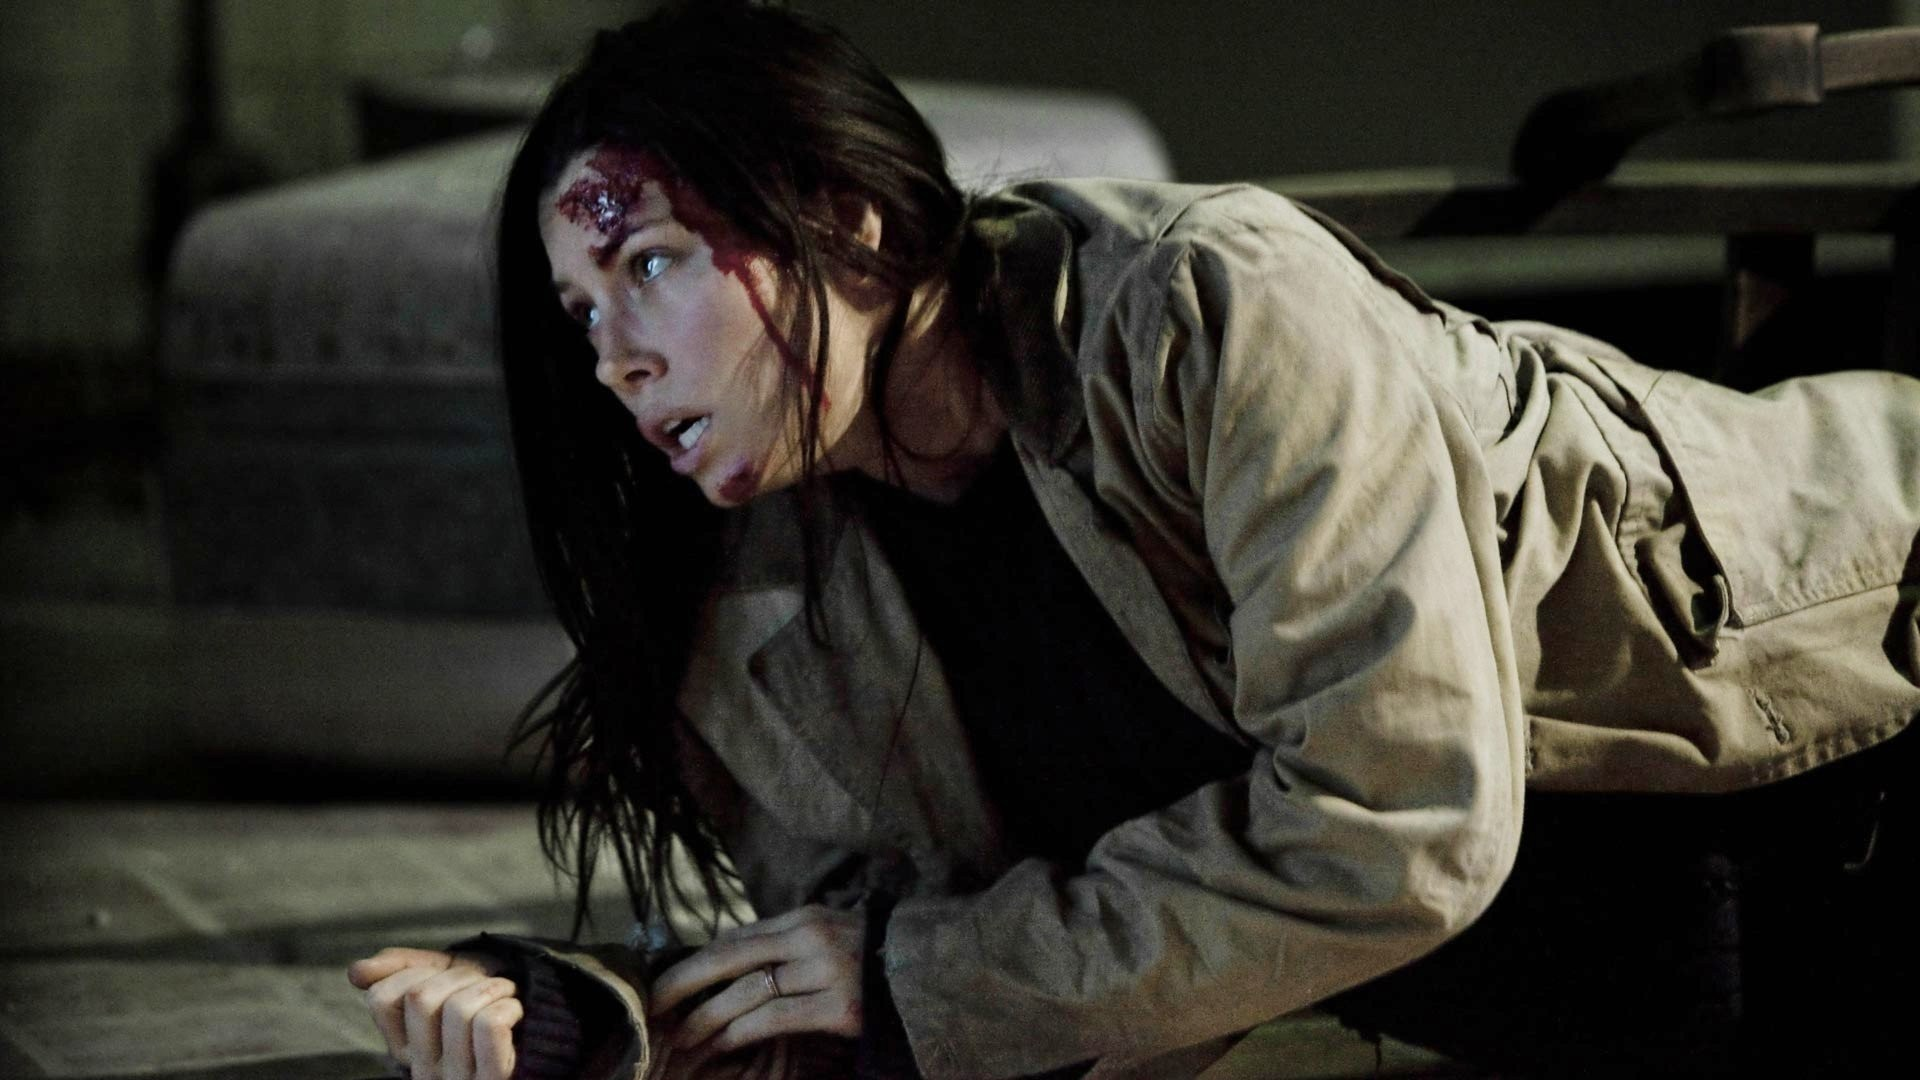Can you tell a background story based on this image? The woman in the image might be a detective who has been pursuing a criminal organization for months. Her investigation led her to an abandoned warehouse where she stumbled upon incriminating evidence. However, the criminals discovered her presence and a violent confrontation ensued, leaving her injured. Now, she is desperately trying to escape to get the evidence to the authorities, despite being wounded. Her determination drives her to crawl to safety, knowing that her mission is critical to bringing justice. 